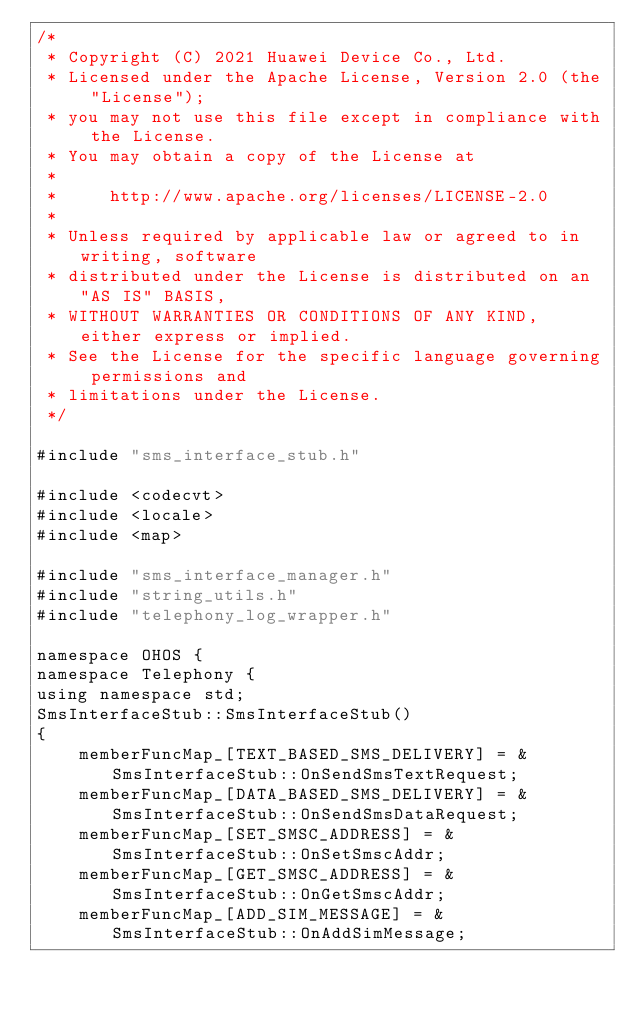Convert code to text. <code><loc_0><loc_0><loc_500><loc_500><_C++_>/*
 * Copyright (C) 2021 Huawei Device Co., Ltd.
 * Licensed under the Apache License, Version 2.0 (the "License");
 * you may not use this file except in compliance with the License.
 * You may obtain a copy of the License at
 *
 *     http://www.apache.org/licenses/LICENSE-2.0
 *
 * Unless required by applicable law or agreed to in writing, software
 * distributed under the License is distributed on an "AS IS" BASIS,
 * WITHOUT WARRANTIES OR CONDITIONS OF ANY KIND, either express or implied.
 * See the License for the specific language governing permissions and
 * limitations under the License.
 */

#include "sms_interface_stub.h"

#include <codecvt>
#include <locale>
#include <map>

#include "sms_interface_manager.h"
#include "string_utils.h"
#include "telephony_log_wrapper.h"

namespace OHOS {
namespace Telephony {
using namespace std;
SmsInterfaceStub::SmsInterfaceStub()
{
    memberFuncMap_[TEXT_BASED_SMS_DELIVERY] = &SmsInterfaceStub::OnSendSmsTextRequest;
    memberFuncMap_[DATA_BASED_SMS_DELIVERY] = &SmsInterfaceStub::OnSendSmsDataRequest;
    memberFuncMap_[SET_SMSC_ADDRESS] = &SmsInterfaceStub::OnSetSmscAddr;
    memberFuncMap_[GET_SMSC_ADDRESS] = &SmsInterfaceStub::OnGetSmscAddr;
    memberFuncMap_[ADD_SIM_MESSAGE] = &SmsInterfaceStub::OnAddSimMessage;</code> 